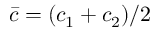<formula> <loc_0><loc_0><loc_500><loc_500>\bar { c } = ( c _ { 1 } + c _ { 2 } ) / 2</formula> 